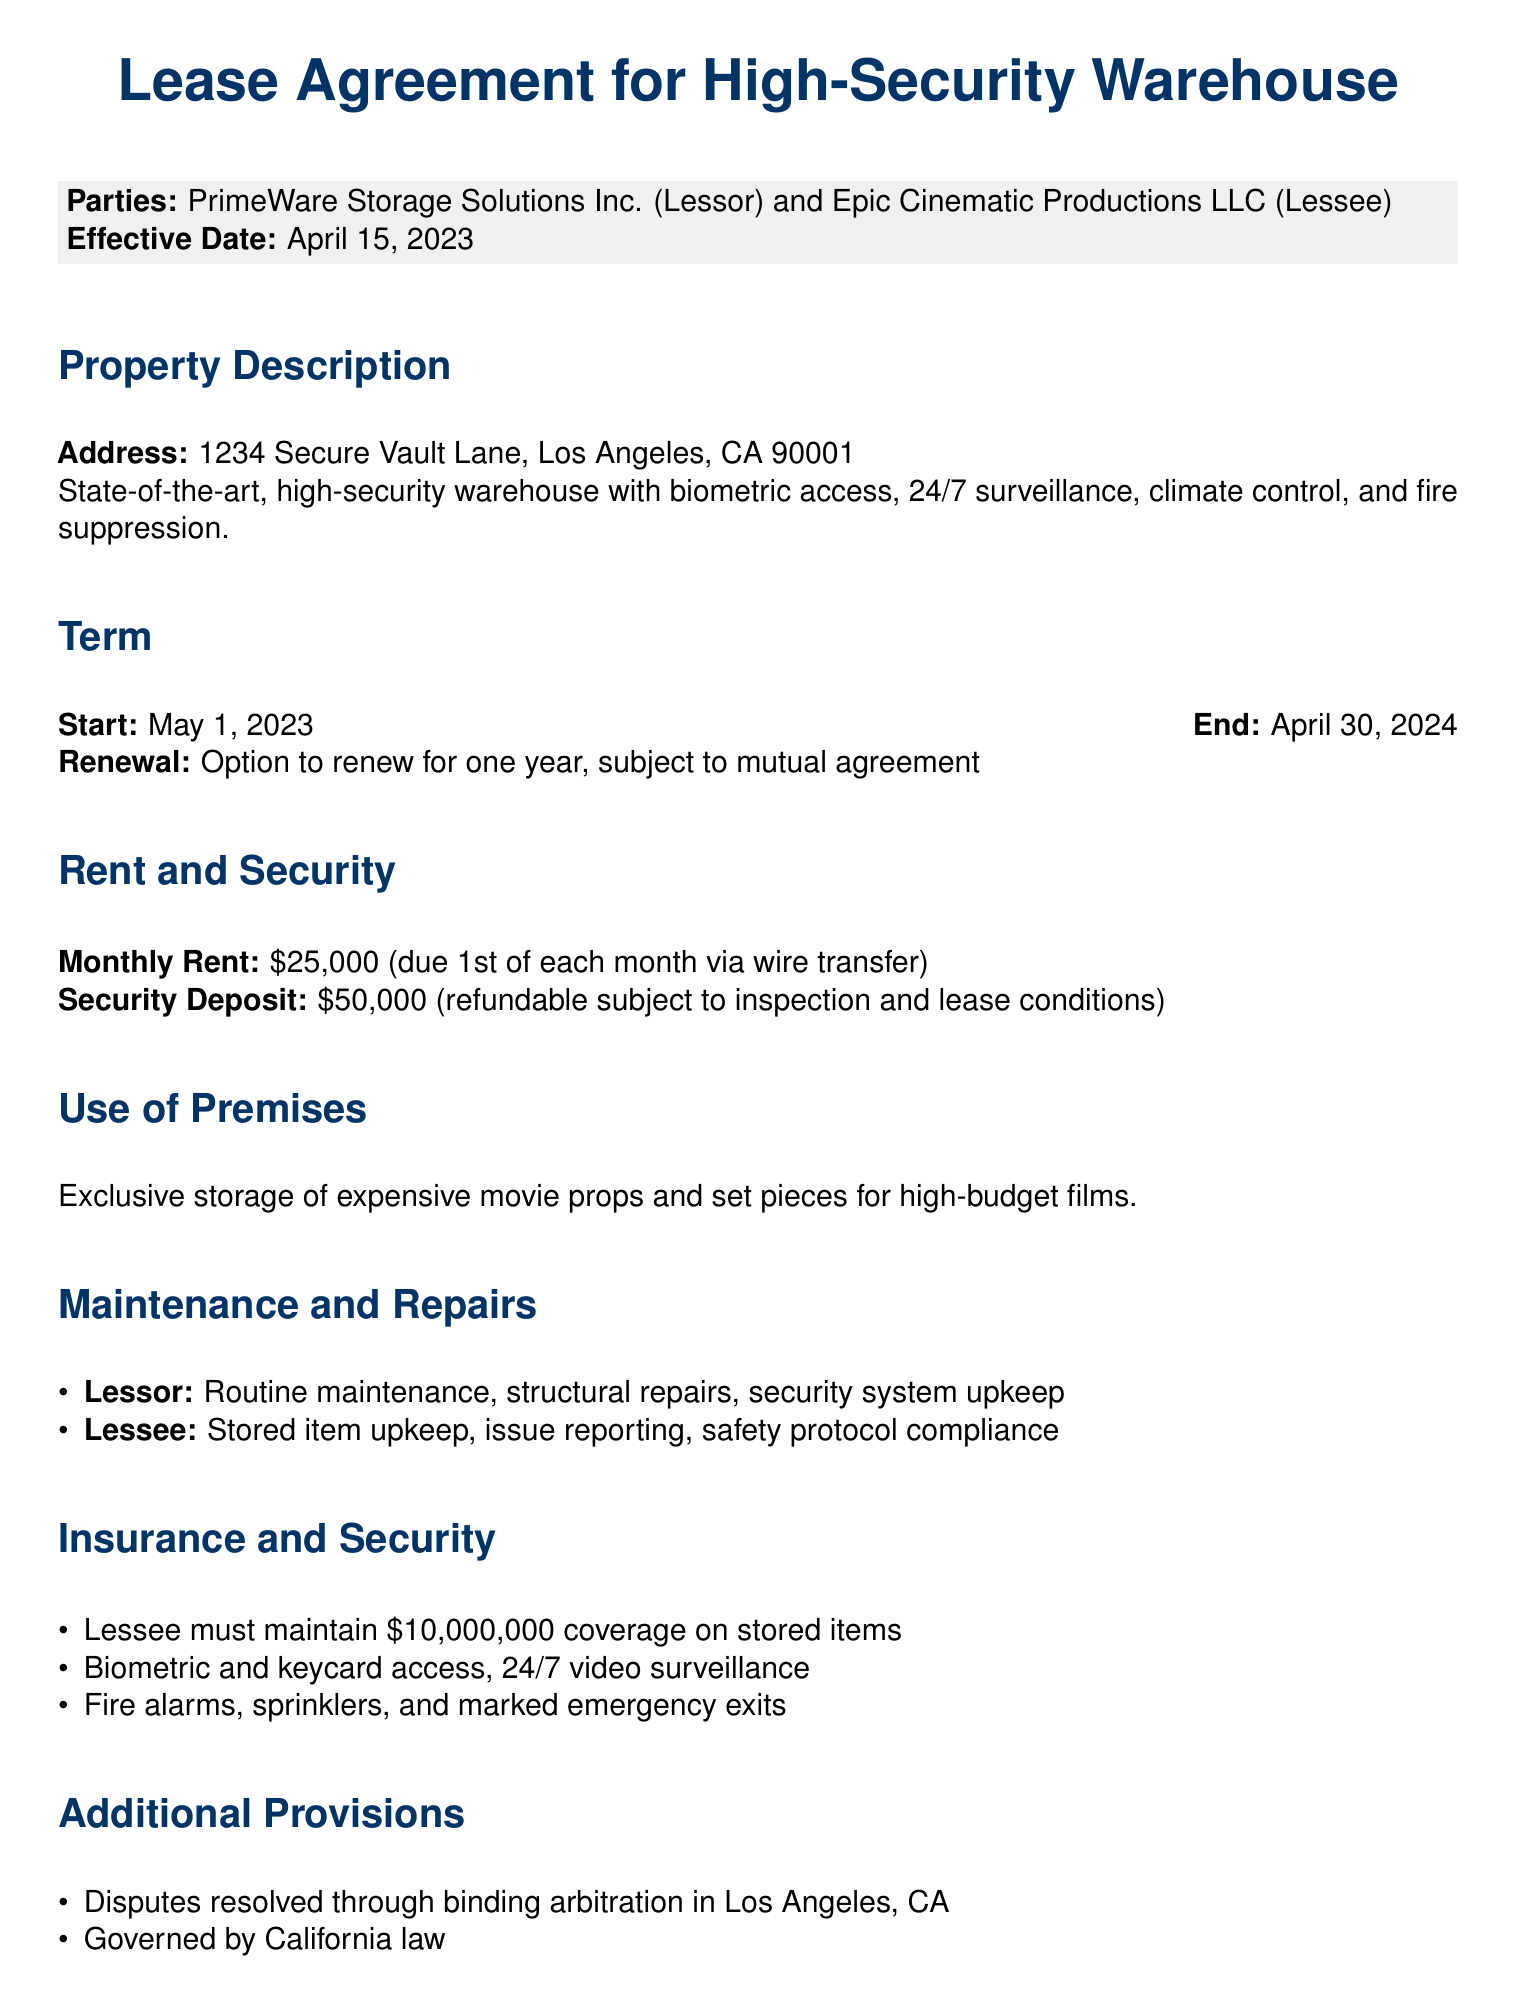What is the address of the warehouse? The address is specified in the property description section of the document.
Answer: 1234 Secure Vault Lane, Los Angeles, CA 90001 What is the start date of the lease? The start date is listed in the term section of the document.
Answer: May 1, 2023 What is the monthly rent? The monthly rent is mentioned in the rent and security section of the document.
Answer: $25,000 What is the security deposit amount? The security deposit is provided in the rent and security section of the document.
Answer: $50,000 Who is responsible for routine maintenance? Responsibilities for maintenance are detailed in the maintenance and repairs section of the document.
Answer: Lessor What is the insurance coverage required for stored items? The insurance requirement is stated in the insurance and security section of the document.
Answer: $10,000,000 What method is used for dispute resolution? The method for resolving disputes is described in the additional provisions section of the document.
Answer: Binding arbitration For how long can the lease be renewed? The renewal option is mentioned in the term section of the document.
Answer: One year 